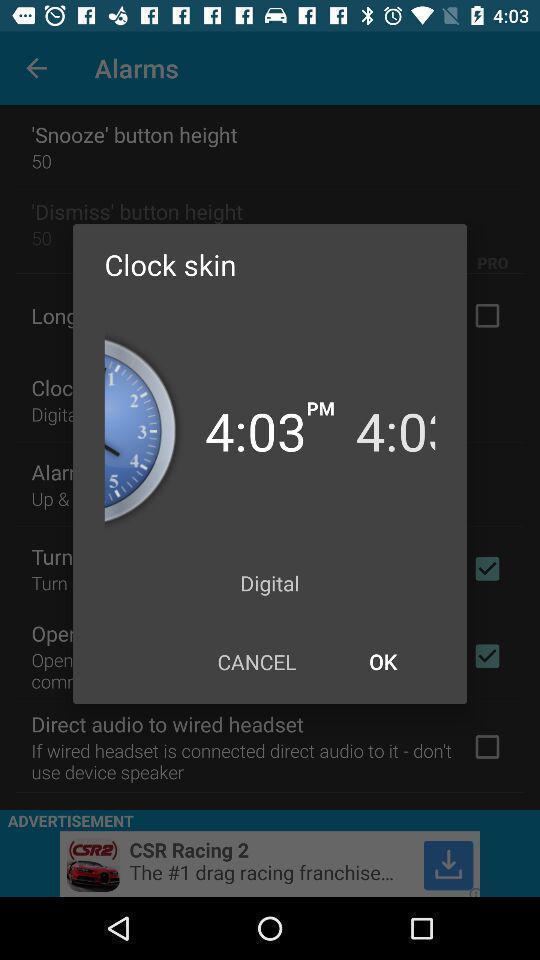Describe the content in this image. Pop-up for setting clock skin time on alarm app. 